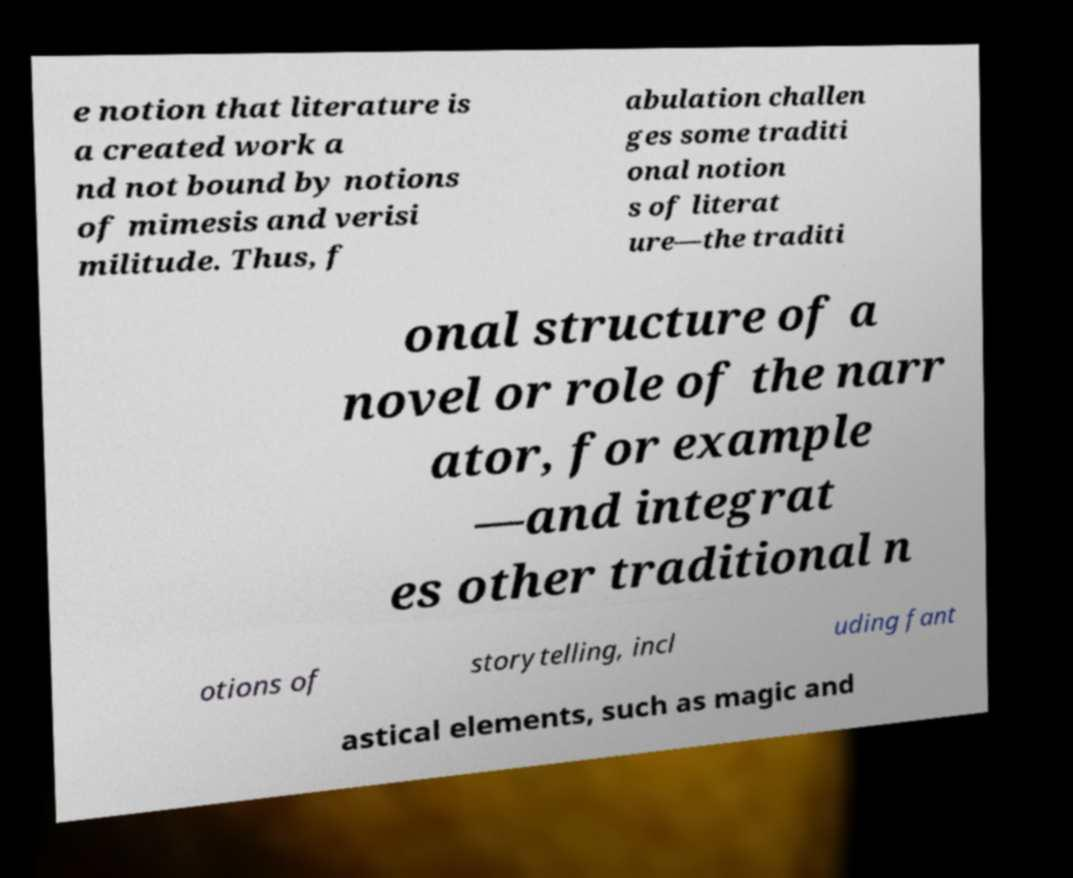Could you assist in decoding the text presented in this image and type it out clearly? e notion that literature is a created work a nd not bound by notions of mimesis and verisi militude. Thus, f abulation challen ges some traditi onal notion s of literat ure—the traditi onal structure of a novel or role of the narr ator, for example —and integrat es other traditional n otions of storytelling, incl uding fant astical elements, such as magic and 